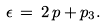Convert formula to latex. <formula><loc_0><loc_0><loc_500><loc_500>\epsilon \, = \, 2 \, p + p _ { 3 } .</formula> 